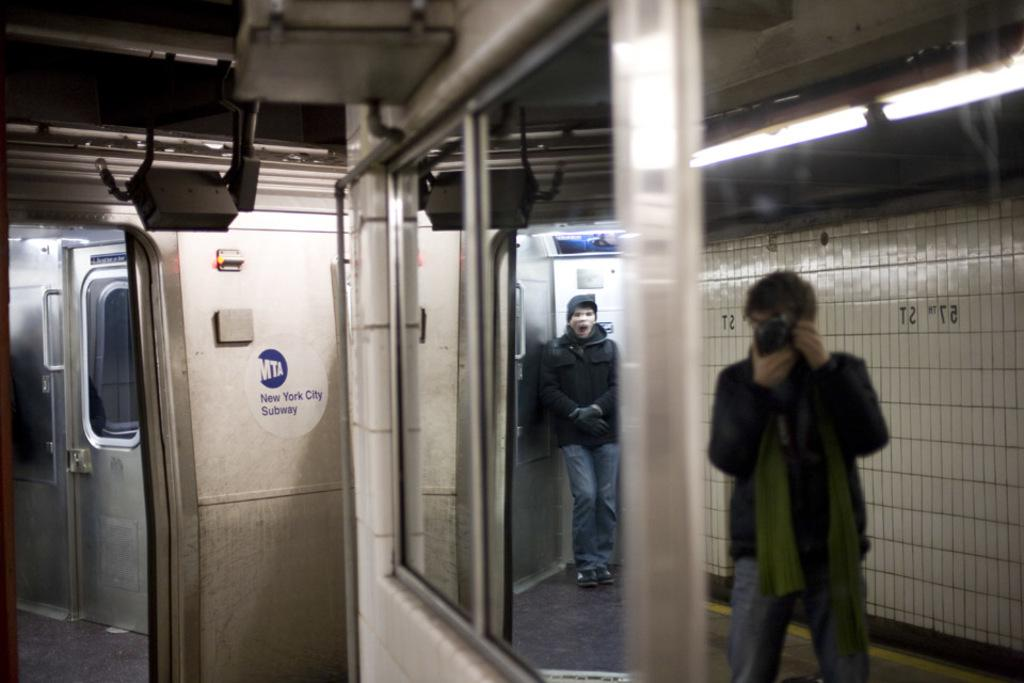<image>
Offer a succinct explanation of the picture presented. some people in the New York City Subway 